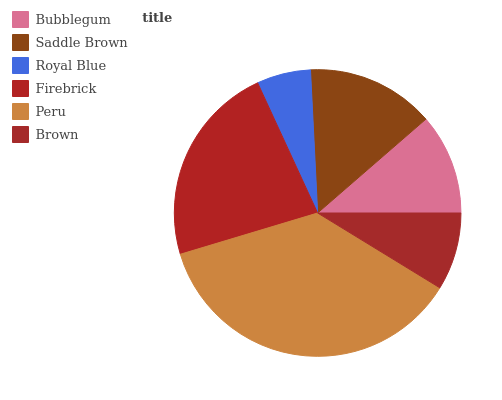Is Royal Blue the minimum?
Answer yes or no. Yes. Is Peru the maximum?
Answer yes or no. Yes. Is Saddle Brown the minimum?
Answer yes or no. No. Is Saddle Brown the maximum?
Answer yes or no. No. Is Saddle Brown greater than Bubblegum?
Answer yes or no. Yes. Is Bubblegum less than Saddle Brown?
Answer yes or no. Yes. Is Bubblegum greater than Saddle Brown?
Answer yes or no. No. Is Saddle Brown less than Bubblegum?
Answer yes or no. No. Is Saddle Brown the high median?
Answer yes or no. Yes. Is Bubblegum the low median?
Answer yes or no. Yes. Is Bubblegum the high median?
Answer yes or no. No. Is Saddle Brown the low median?
Answer yes or no. No. 